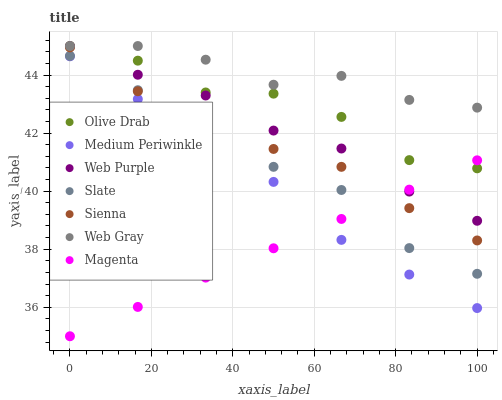Does Magenta have the minimum area under the curve?
Answer yes or no. Yes. Does Web Gray have the maximum area under the curve?
Answer yes or no. Yes. Does Slate have the minimum area under the curve?
Answer yes or no. No. Does Slate have the maximum area under the curve?
Answer yes or no. No. Is Magenta the smoothest?
Answer yes or no. Yes. Is Olive Drab the roughest?
Answer yes or no. Yes. Is Slate the smoothest?
Answer yes or no. No. Is Slate the roughest?
Answer yes or no. No. Does Magenta have the lowest value?
Answer yes or no. Yes. Does Slate have the lowest value?
Answer yes or no. No. Does Olive Drab have the highest value?
Answer yes or no. Yes. Does Slate have the highest value?
Answer yes or no. No. Is Magenta less than Web Gray?
Answer yes or no. Yes. Is Olive Drab greater than Web Purple?
Answer yes or no. Yes. Does Medium Periwinkle intersect Magenta?
Answer yes or no. Yes. Is Medium Periwinkle less than Magenta?
Answer yes or no. No. Is Medium Periwinkle greater than Magenta?
Answer yes or no. No. Does Magenta intersect Web Gray?
Answer yes or no. No. 